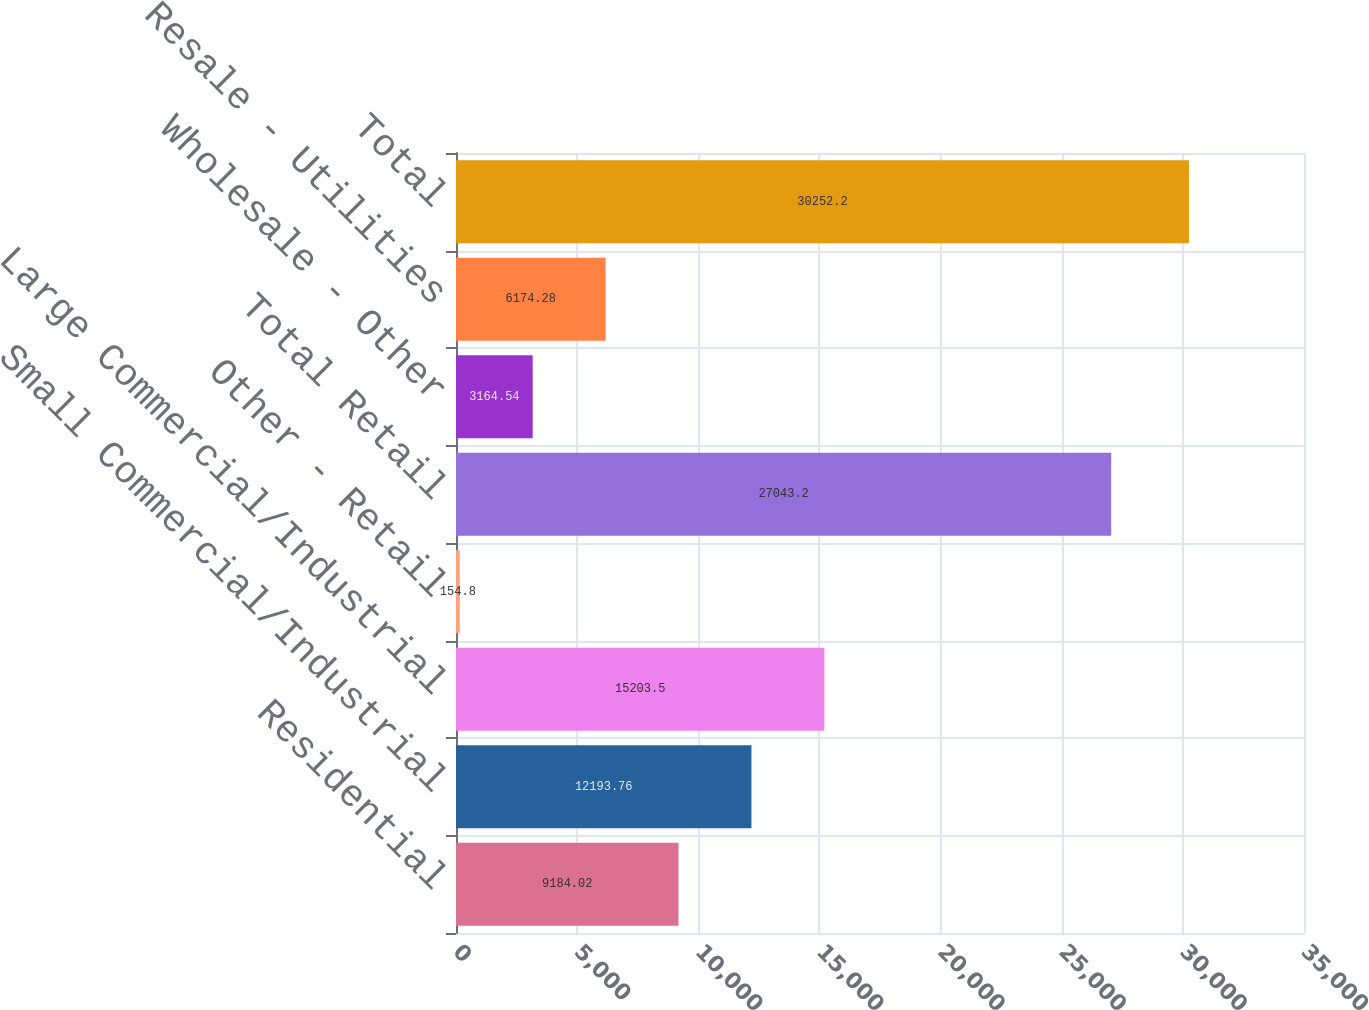Convert chart. <chart><loc_0><loc_0><loc_500><loc_500><bar_chart><fcel>Residential<fcel>Small Commercial/Industrial<fcel>Large Commercial/Industrial<fcel>Other - Retail<fcel>Total Retail<fcel>Wholesale - Other<fcel>Resale - Utilities<fcel>Total<nl><fcel>9184.02<fcel>12193.8<fcel>15203.5<fcel>154.8<fcel>27043.2<fcel>3164.54<fcel>6174.28<fcel>30252.2<nl></chart> 